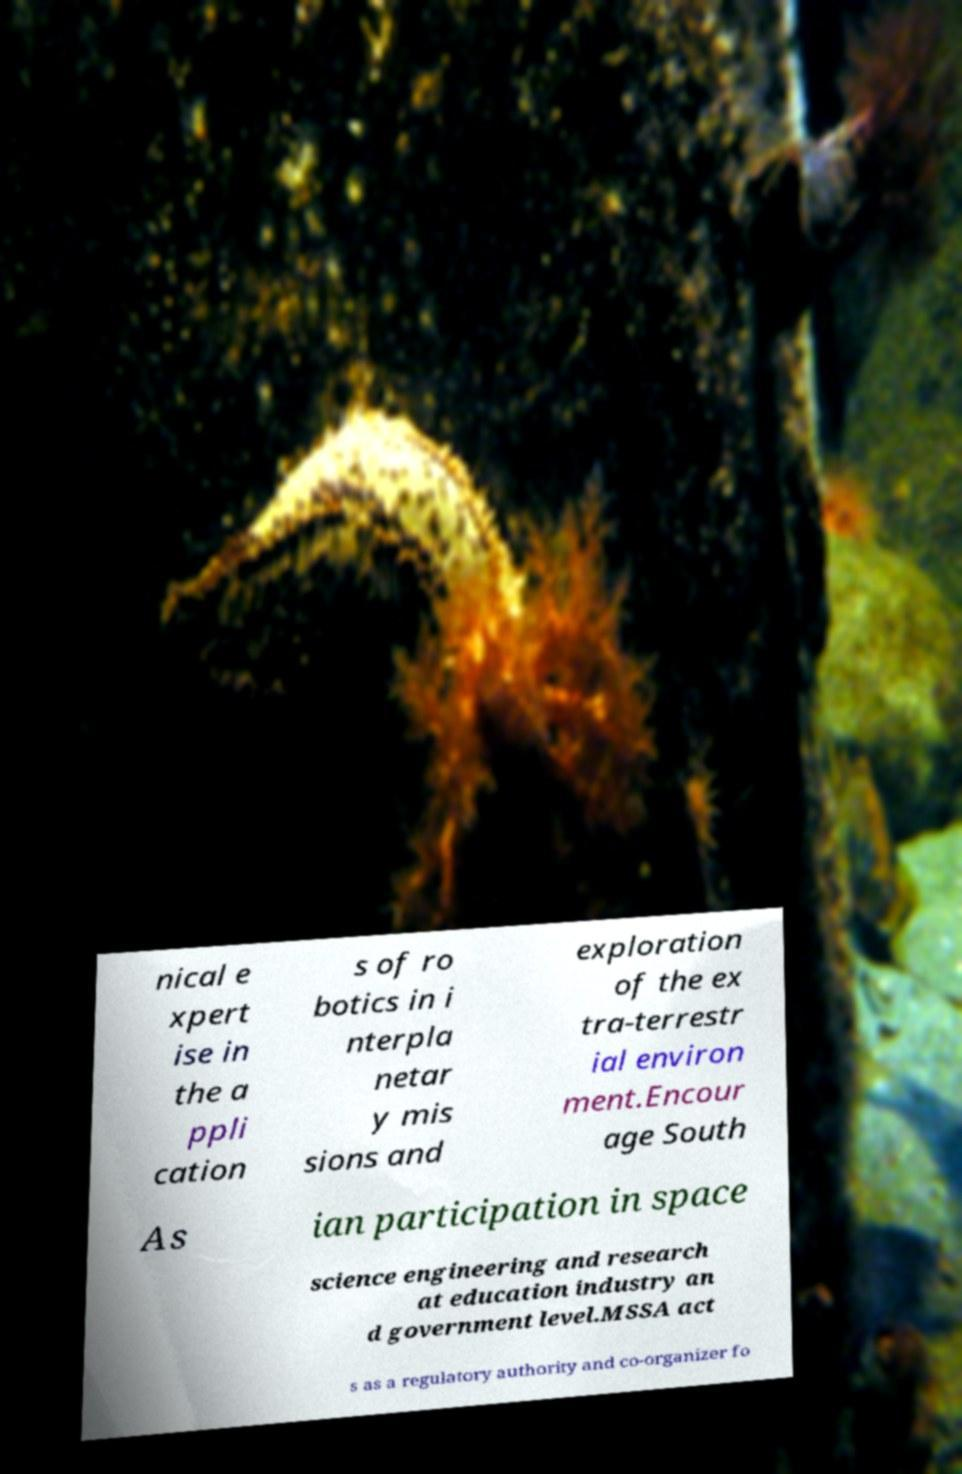Please read and relay the text visible in this image. What does it say? nical e xpert ise in the a ppli cation s of ro botics in i nterpla netar y mis sions and exploration of the ex tra-terrestr ial environ ment.Encour age South As ian participation in space science engineering and research at education industry an d government level.MSSA act s as a regulatory authority and co-organizer fo 